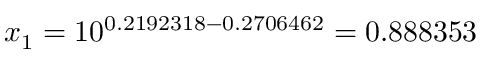<formula> <loc_0><loc_0><loc_500><loc_500>x _ { 1 } = 1 0 ^ { 0 . 2 1 9 2 3 1 8 - 0 . 2 7 0 6 4 6 2 } = 0 . 8 8 8 3 5 3</formula> 